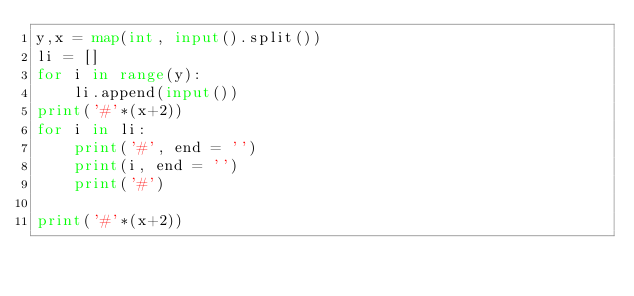Convert code to text. <code><loc_0><loc_0><loc_500><loc_500><_Python_>y,x = map(int, input().split())
li = []
for i in range(y):
    li.append(input())
print('#'*(x+2))
for i in li:
    print('#', end = '')
    print(i, end = '')
    print('#')

print('#'*(x+2))
</code> 